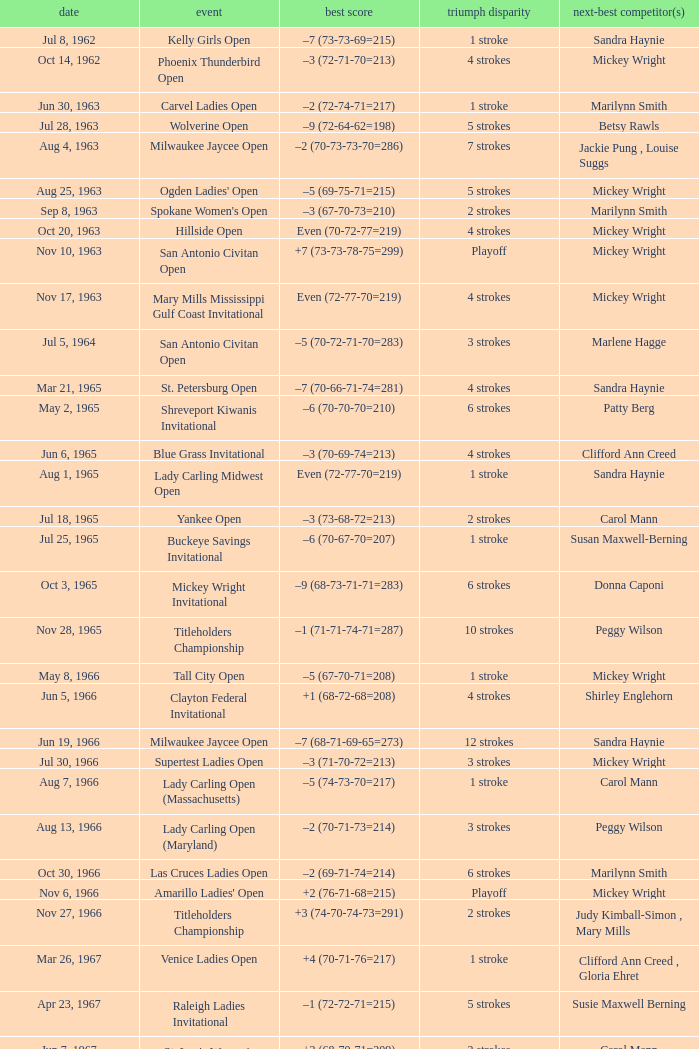What was the winning score when there were 9 strokes advantage? –7 (73-68-73-67=281). 